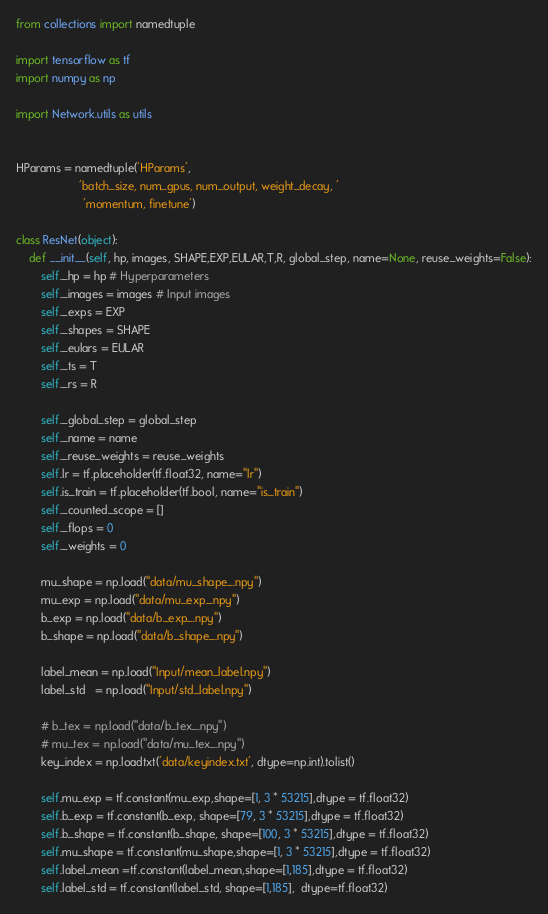<code> <loc_0><loc_0><loc_500><loc_500><_Python_>from collections import namedtuple

import tensorflow as tf
import numpy as np

import Network.utils as utils


HParams = namedtuple('HParams',
                    'batch_size, num_gpus, num_output, weight_decay, '
                     'momentum, finetune')

class ResNet(object):
    def __init__(self, hp, images, SHAPE,EXP,EULAR,T,R, global_step, name=None, reuse_weights=False):
        self._hp = hp # Hyperparameters
        self._images = images # Input images
        self._exps = EXP
        self._shapes = SHAPE
        self._eulars = EULAR
        self._ts = T
        self._rs = R

        self._global_step = global_step
        self._name = name
        self._reuse_weights = reuse_weights
        self.lr = tf.placeholder(tf.float32, name="lr")
        self.is_train = tf.placeholder(tf.bool, name="is_train")
        self._counted_scope = []
        self._flops = 0
        self._weights = 0

        mu_shape = np.load("data/mu_shape_.npy")
        mu_exp = np.load("data/mu_exp_.npy")
        b_exp = np.load("data/b_exp_.npy")
        b_shape = np.load("data/b_shape_.npy")

        label_mean = np.load("Input/mean_label.npy")
        label_std   = np.load("Input/std_label.npy")

        # b_tex = np.load("data/b_tex_.npy")
        # mu_tex = np.load("data/mu_tex_.npy")
        key_index = np.loadtxt('data/keyindex.txt', dtype=np.int).tolist()

        self.mu_exp = tf.constant(mu_exp,shape=[1, 3 * 53215],dtype = tf.float32)
        self.b_exp = tf.constant(b_exp, shape=[79, 3 * 53215],dtype = tf.float32)
        self.b_shape = tf.constant(b_shape, shape=[100, 3 * 53215],dtype = tf.float32)
        self.mu_shape = tf.constant(mu_shape,shape=[1, 3 * 53215],dtype = tf.float32)
        self.label_mean =tf.constant(label_mean,shape=[1,185],dtype = tf.float32)
        self.label_std = tf.constant(label_std, shape=[1,185],  dtype=tf.float32)</code> 